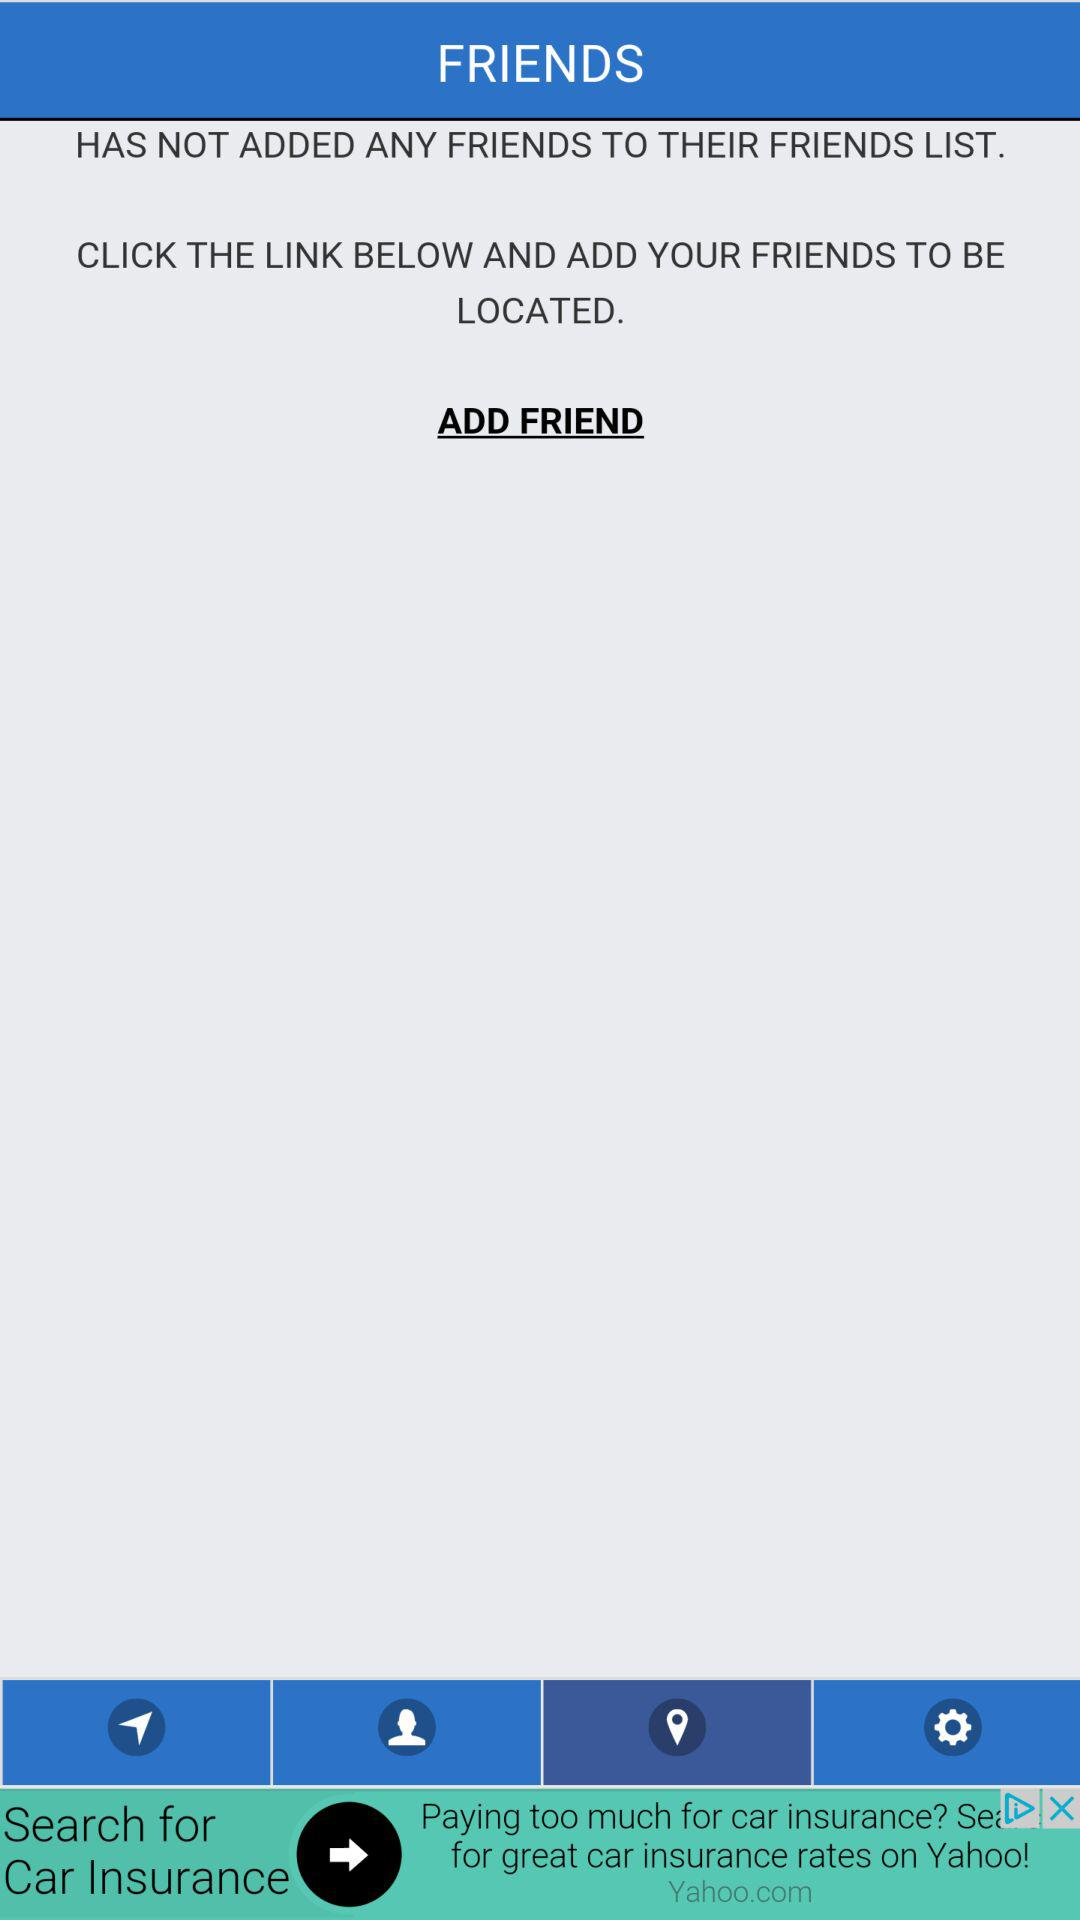Are there any friends added to the list? There are no friends added to the list. 